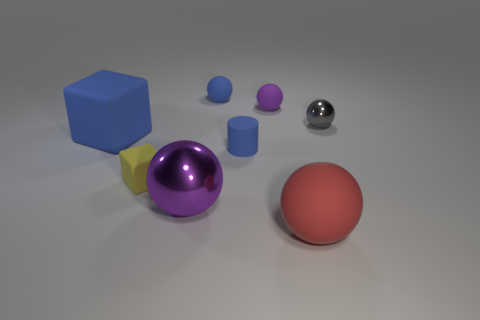Is there any object in the shadow? Yes, the yellow four-sided figure is partly in shadow, with its left side less illuminated than its right, creating a contrast that highlights its three-dimensional shape. 